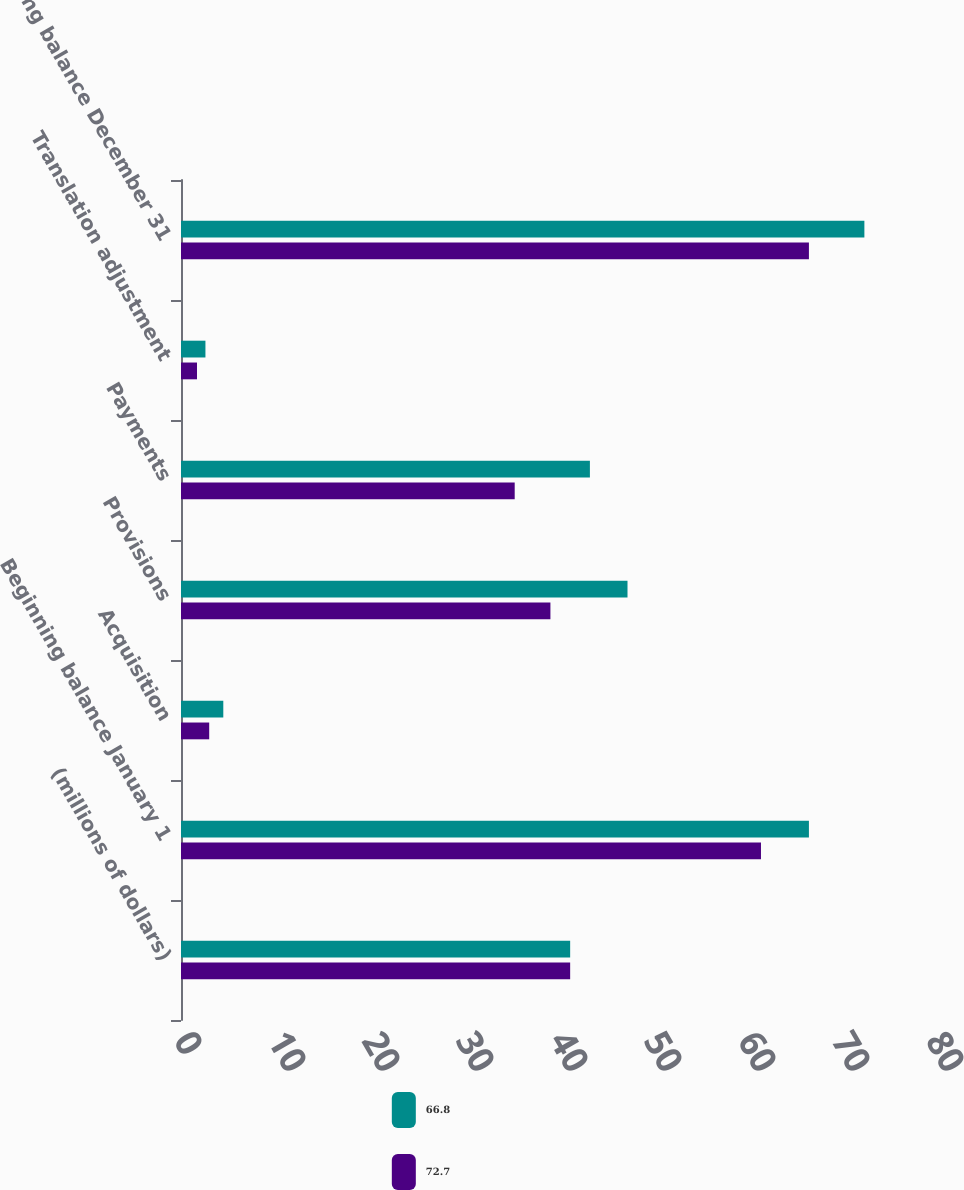Convert chart to OTSL. <chart><loc_0><loc_0><loc_500><loc_500><stacked_bar_chart><ecel><fcel>(millions of dollars)<fcel>Beginning balance January 1<fcel>Acquisition<fcel>Provisions<fcel>Payments<fcel>Translation adjustment<fcel>Ending balance December 31<nl><fcel>66.8<fcel>41.4<fcel>66.8<fcel>4.5<fcel>47.5<fcel>43.5<fcel>2.6<fcel>72.7<nl><fcel>72.7<fcel>41.4<fcel>61.7<fcel>3<fcel>39.3<fcel>35.5<fcel>1.7<fcel>66.8<nl></chart> 